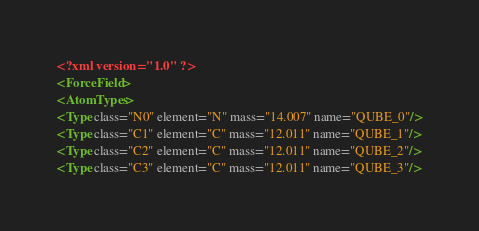<code> <loc_0><loc_0><loc_500><loc_500><_XML_><?xml version="1.0" ?>
<ForceField>
<AtomTypes>
<Type class="N0" element="N" mass="14.007" name="QUBE_0"/>
<Type class="C1" element="C" mass="12.011" name="QUBE_1"/>
<Type class="C2" element="C" mass="12.011" name="QUBE_2"/>
<Type class="C3" element="C" mass="12.011" name="QUBE_3"/></code> 